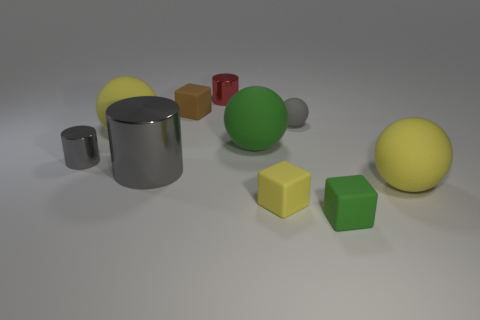What number of things are either big yellow rubber spheres to the left of the green rubber block or matte blocks?
Your response must be concise. 4. What shape is the small gray object that is behind the tiny shiny object in front of the small ball?
Your answer should be very brief. Sphere. Is there a brown rubber thing that has the same size as the brown matte cube?
Your response must be concise. No. Are there more yellow spheres than large cyan balls?
Your response must be concise. Yes. Is the size of the yellow rubber ball on the right side of the tiny green matte cube the same as the matte thing on the left side of the brown matte cube?
Your response must be concise. Yes. How many yellow things are to the right of the big gray object and on the left side of the small red metallic object?
Keep it short and to the point. 0. What is the color of the large thing that is the same shape as the tiny red metallic object?
Make the answer very short. Gray. Are there fewer yellow balls than matte cubes?
Offer a terse response. Yes. Do the red object and the green matte object that is in front of the big gray metal thing have the same size?
Offer a very short reply. Yes. The big sphere that is on the left side of the small metal cylinder behind the green matte ball is what color?
Your answer should be very brief. Yellow. 